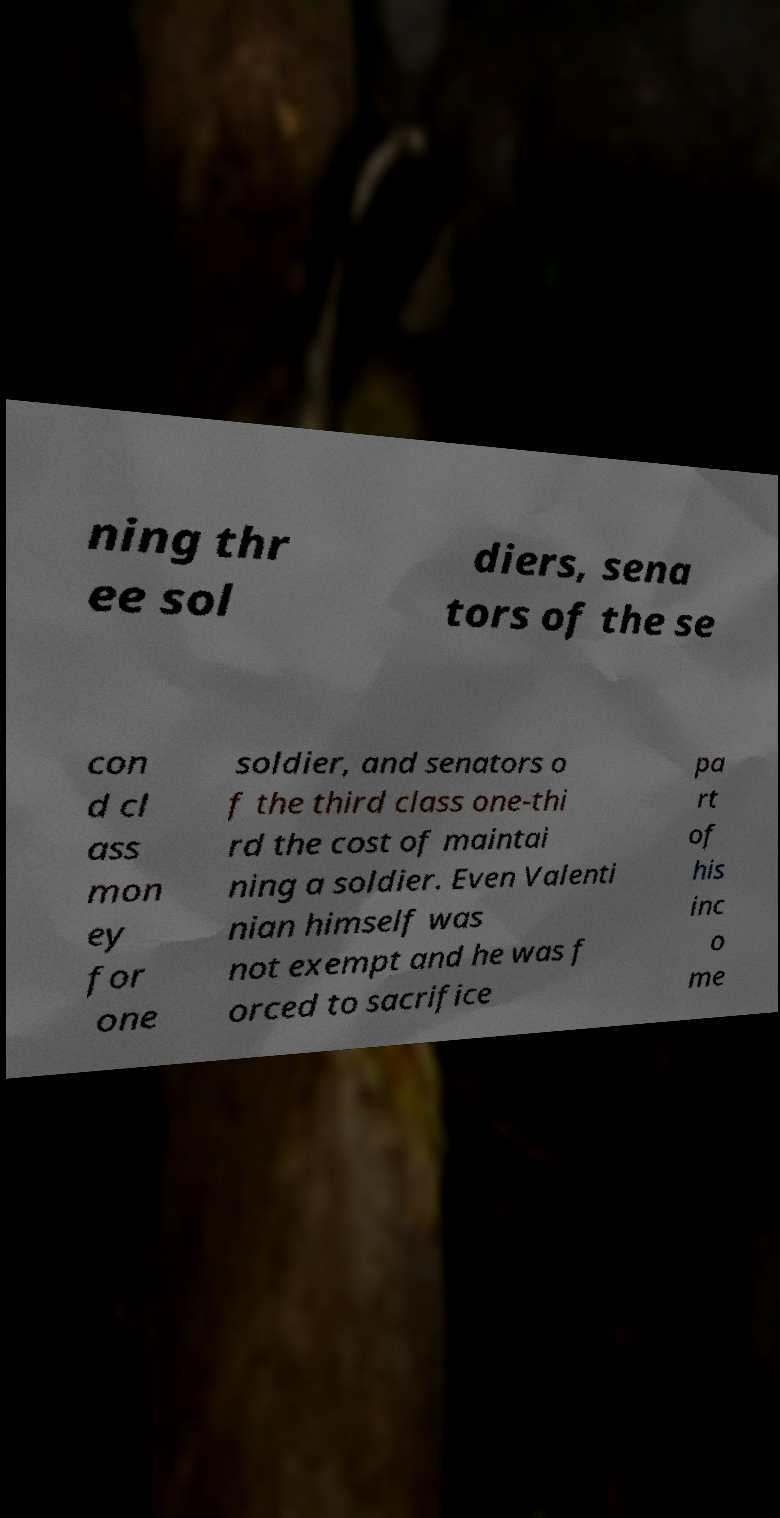Can you accurately transcribe the text from the provided image for me? ning thr ee sol diers, sena tors of the se con d cl ass mon ey for one soldier, and senators o f the third class one-thi rd the cost of maintai ning a soldier. Even Valenti nian himself was not exempt and he was f orced to sacrifice pa rt of his inc o me 